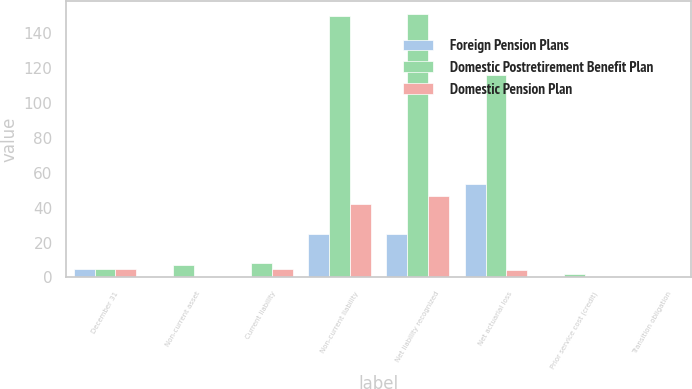Convert chart to OTSL. <chart><loc_0><loc_0><loc_500><loc_500><stacked_bar_chart><ecel><fcel>December 31<fcel>Non-current asset<fcel>Current liability<fcel>Non-current liability<fcel>Net liability recognized<fcel>Net actuarial loss<fcel>Prior service cost (credit)<fcel>Transition obligation<nl><fcel>Foreign Pension Plans<fcel>4.6<fcel>0<fcel>0<fcel>24.9<fcel>24.9<fcel>53.6<fcel>0<fcel>0<nl><fcel>Domestic Postretirement Benefit Plan<fcel>4.6<fcel>7.4<fcel>8.4<fcel>149.7<fcel>150.7<fcel>115.7<fcel>1.8<fcel>0<nl><fcel>Domestic Pension Plan<fcel>4.6<fcel>0<fcel>4.6<fcel>42<fcel>46.6<fcel>4.2<fcel>0.2<fcel>0<nl></chart> 